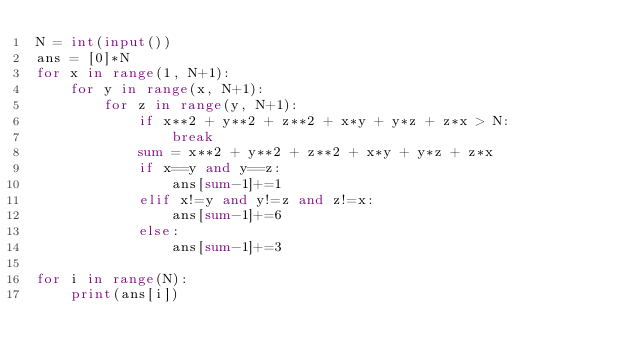<code> <loc_0><loc_0><loc_500><loc_500><_Python_>N = int(input())
ans = [0]*N
for x in range(1, N+1):
    for y in range(x, N+1):
        for z in range(y, N+1):
            if x**2 + y**2 + z**2 + x*y + y*z + z*x > N:
                break
            sum = x**2 + y**2 + z**2 + x*y + y*z + z*x
            if x==y and y==z:
                ans[sum-1]+=1
            elif x!=y and y!=z and z!=x:
                ans[sum-1]+=6
            else:
                ans[sum-1]+=3

for i in range(N):
    print(ans[i])</code> 